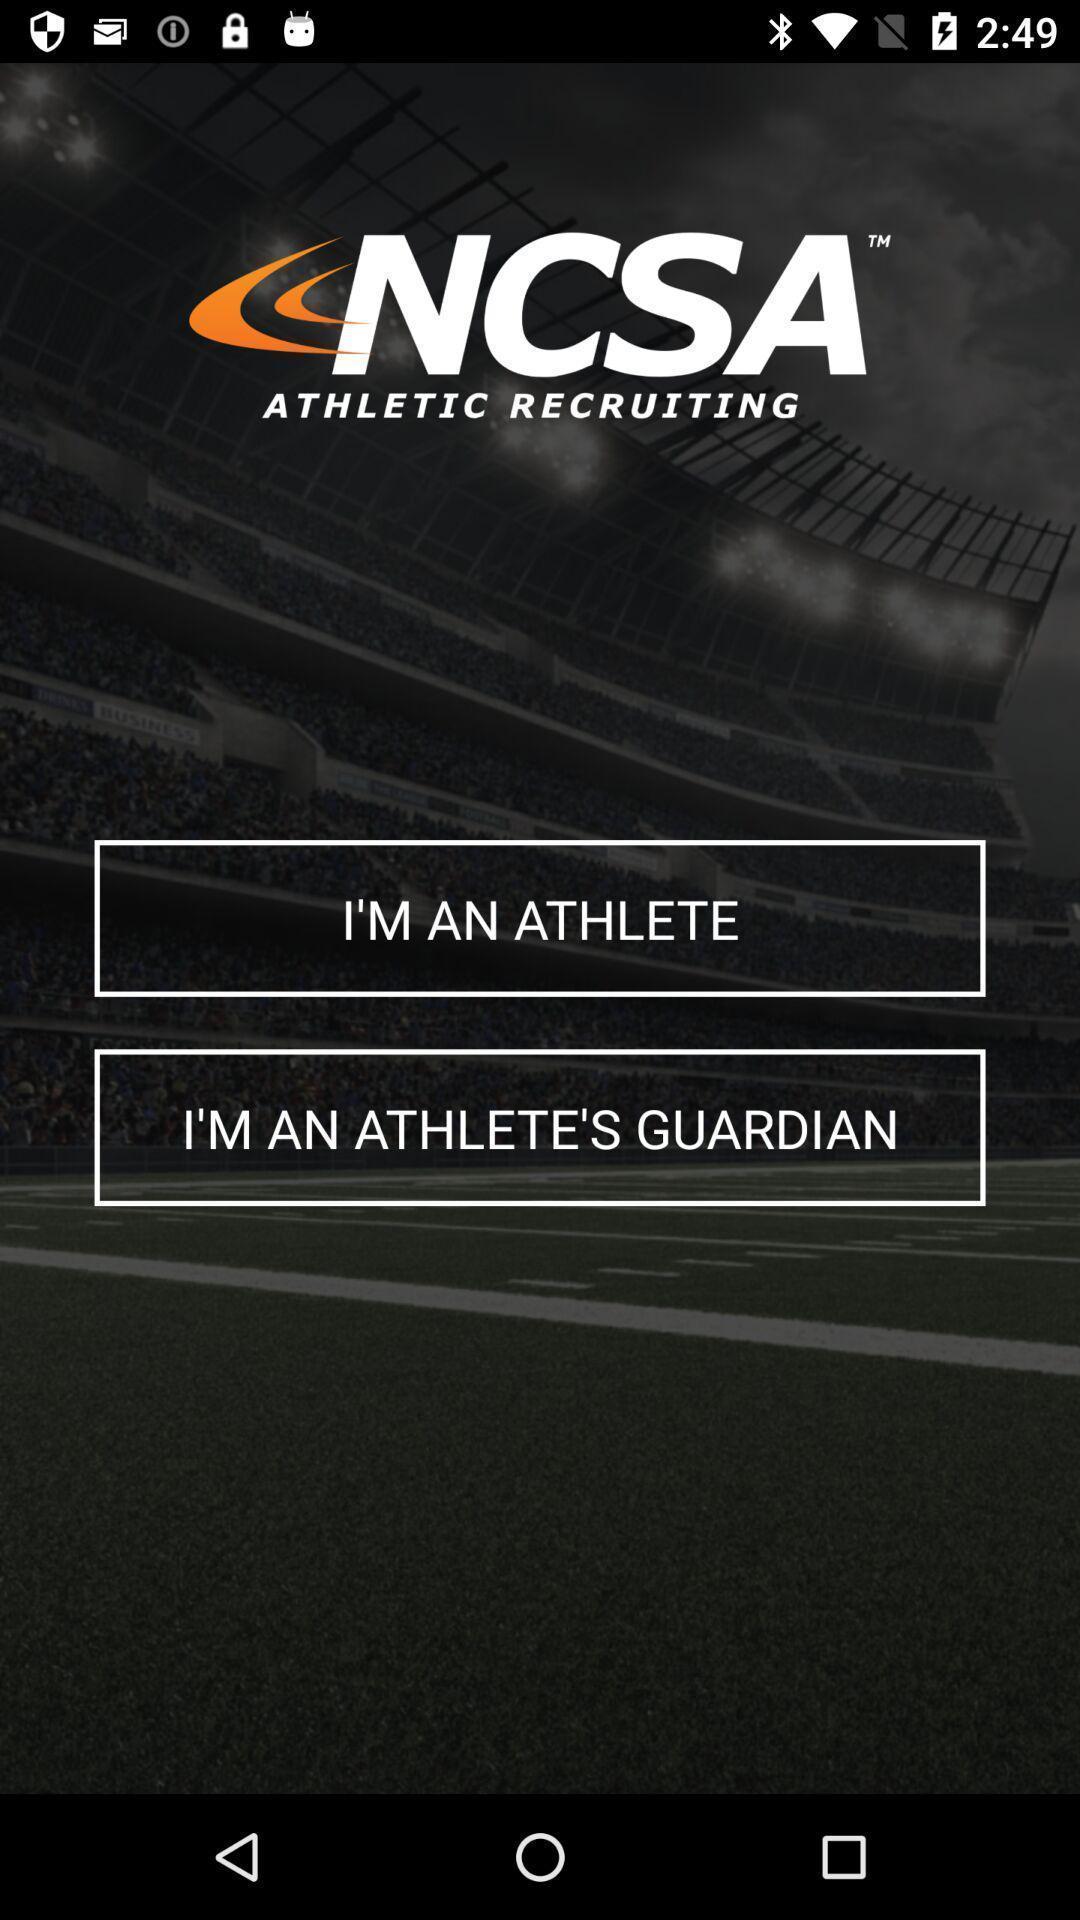Give me a narrative description of this picture. Welcome page of social app. 